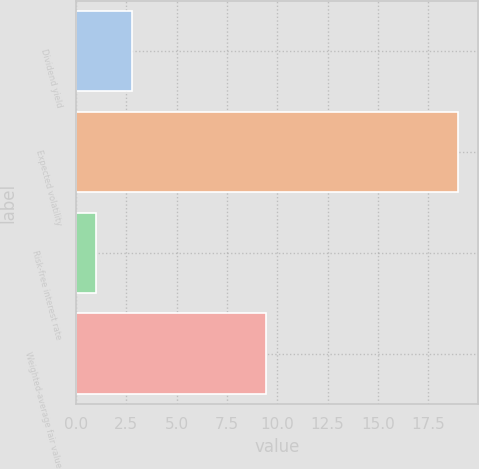Convert chart to OTSL. <chart><loc_0><loc_0><loc_500><loc_500><bar_chart><fcel>Dividend yield<fcel>Expected volatility<fcel>Risk-free interest rate<fcel>Weighted-average fair value<nl><fcel>2.8<fcel>19<fcel>1<fcel>9.46<nl></chart> 